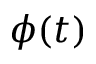<formula> <loc_0><loc_0><loc_500><loc_500>\phi ( t )</formula> 